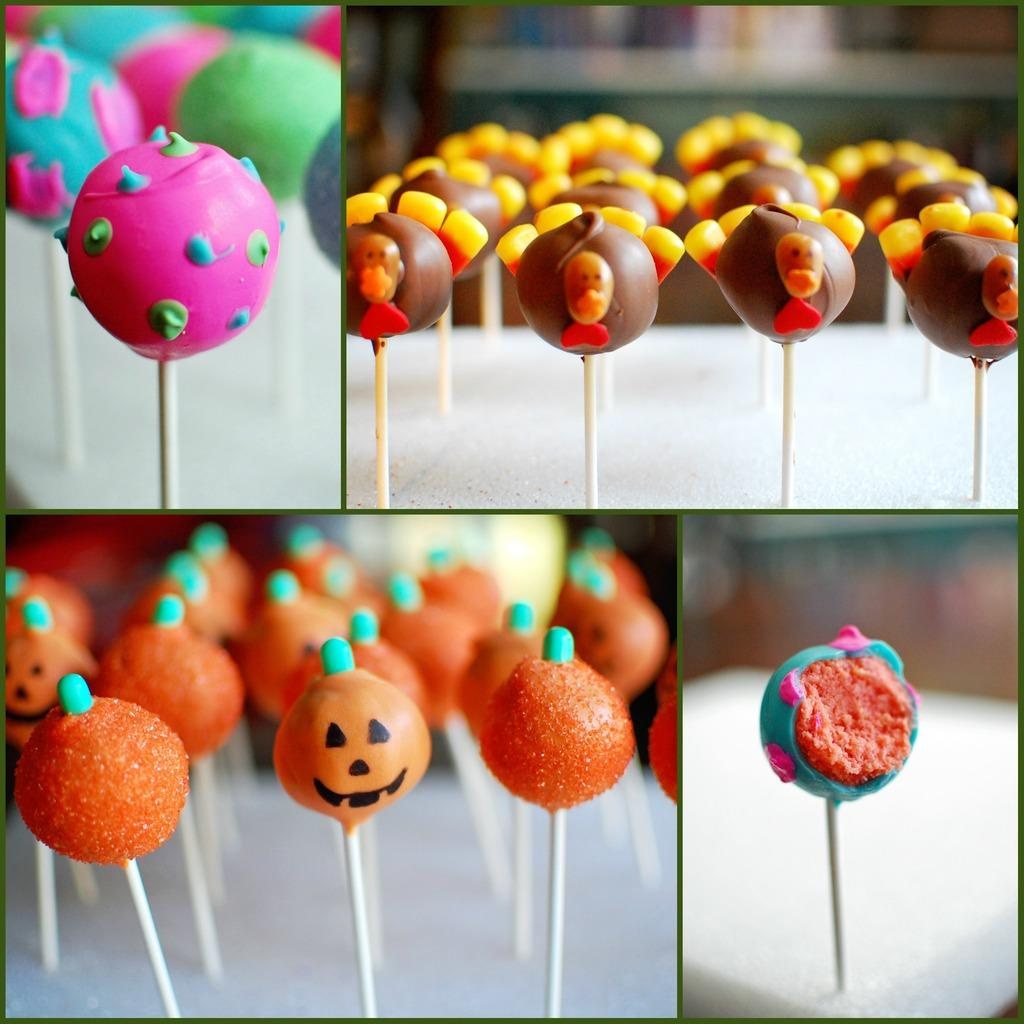What is the composition of the image? The image is a collage of four pictures. What is the common theme among the pictures in the collage? Each picture contains lollipops. How can the lollipops be distinguished from one another in the collage? The lollipops have different colors. Can you tell me how many rats are sitting on the lollipops in the image? There are no rats present in the image; it only features lollipops in different colors. What type of writing can be seen on the lollipops in the image? There is no writing visible on the lollipops in the image. What type of glove is being used to hold the lollipops in the image? There are no gloves present in the image; it only features lollipops in different colors. 